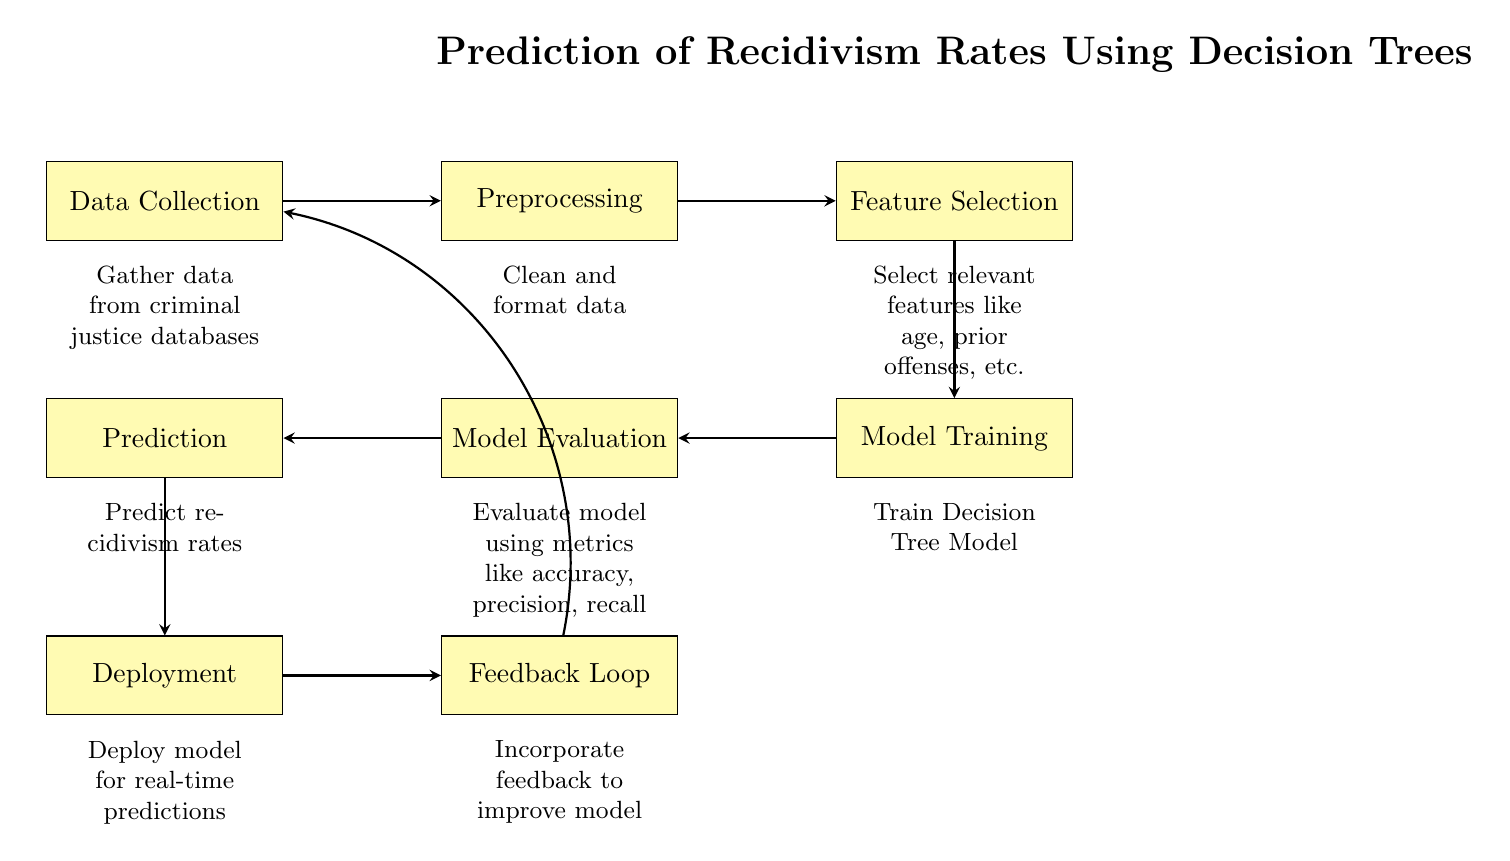What is the first step in the process? The first step in the process is labeled as "Data Collection," which is the starting point for gathering information necessary for further analysis.
Answer: Data Collection What is the last step in the process? The last step in the process is "Feedback Loop," which indicates the final stage where input is used to improve the model.
Answer: Feedback Loop How many main processes are shown in the diagram? The diagram includes a total of 7 main processes, from "Data Collection" to "Feedback Loop," highlighting each key stage in the workflow.
Answer: 7 Which process directly follows "Model Training"? The process that directly follows "Model Training" is "Model Evaluation," which assesses the performance of the trained model against certain metrics.
Answer: Model Evaluation What type of model is being trained in this diagram? The diagram specifically mentions that a "Decision Tree Model" is being trained during the model training phase.
Answer: Decision Tree Model What type of features are selected during feature selection? During the "Feature Selection" phase, relevant features like "age" and "prior offenses" are selected to help predict recidivism rates.
Answer: age, prior offenses What is done after "Model Evaluation"? After "Model Evaluation," the next step is "Prediction," where the model is used to make predictions regarding recidivism rates based on the evaluated model.
Answer: Prediction What is the purpose of the "Feedback Loop" in this diagram? The "Feedback Loop" is meant to incorporate feedback to improve the model, indicating that the system allows for iterative enhancements based on performance or user input.
Answer: Improve model What are the evaluation metrics mentioned in the diagram? The evaluation metrics used in "Model Evaluation" include "accuracy," "precision," and "recall," which help gauge the model's performance effectively.
Answer: accuracy, precision, recall 